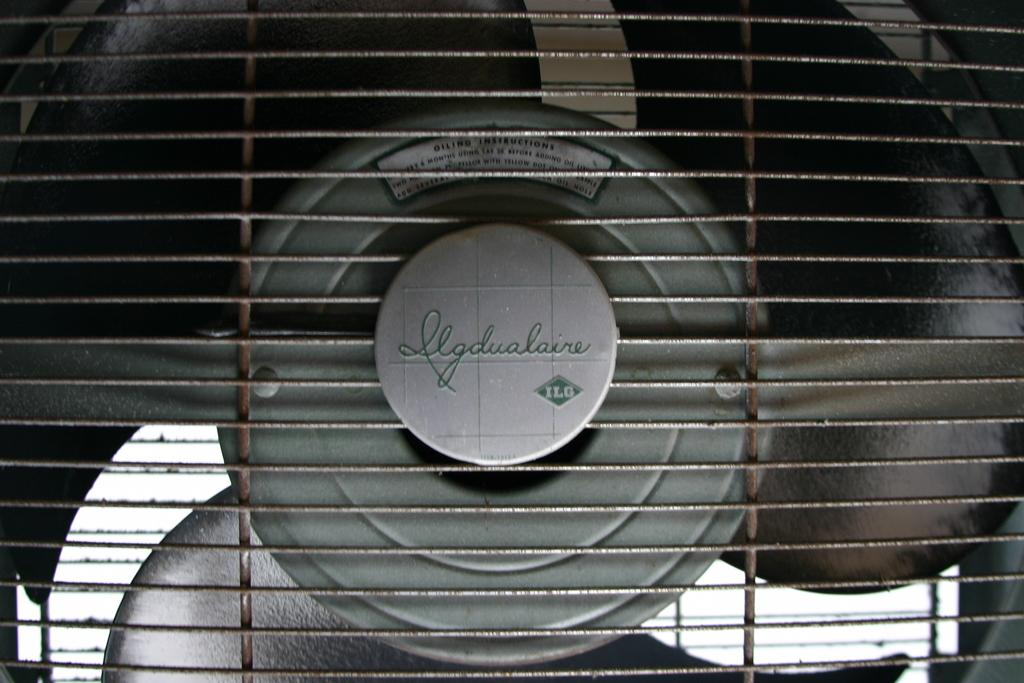What appliance is visible in the image? There is a fan in the image. What cooking device is also present in the image? There is a grill in the image. Is there any writing or text on the grill? Yes, there is text on the grill. Can you tell me the name of the woman who lives in the town depicted on the grill? There is no woman or town depicted on the grill; it only has text on it. 